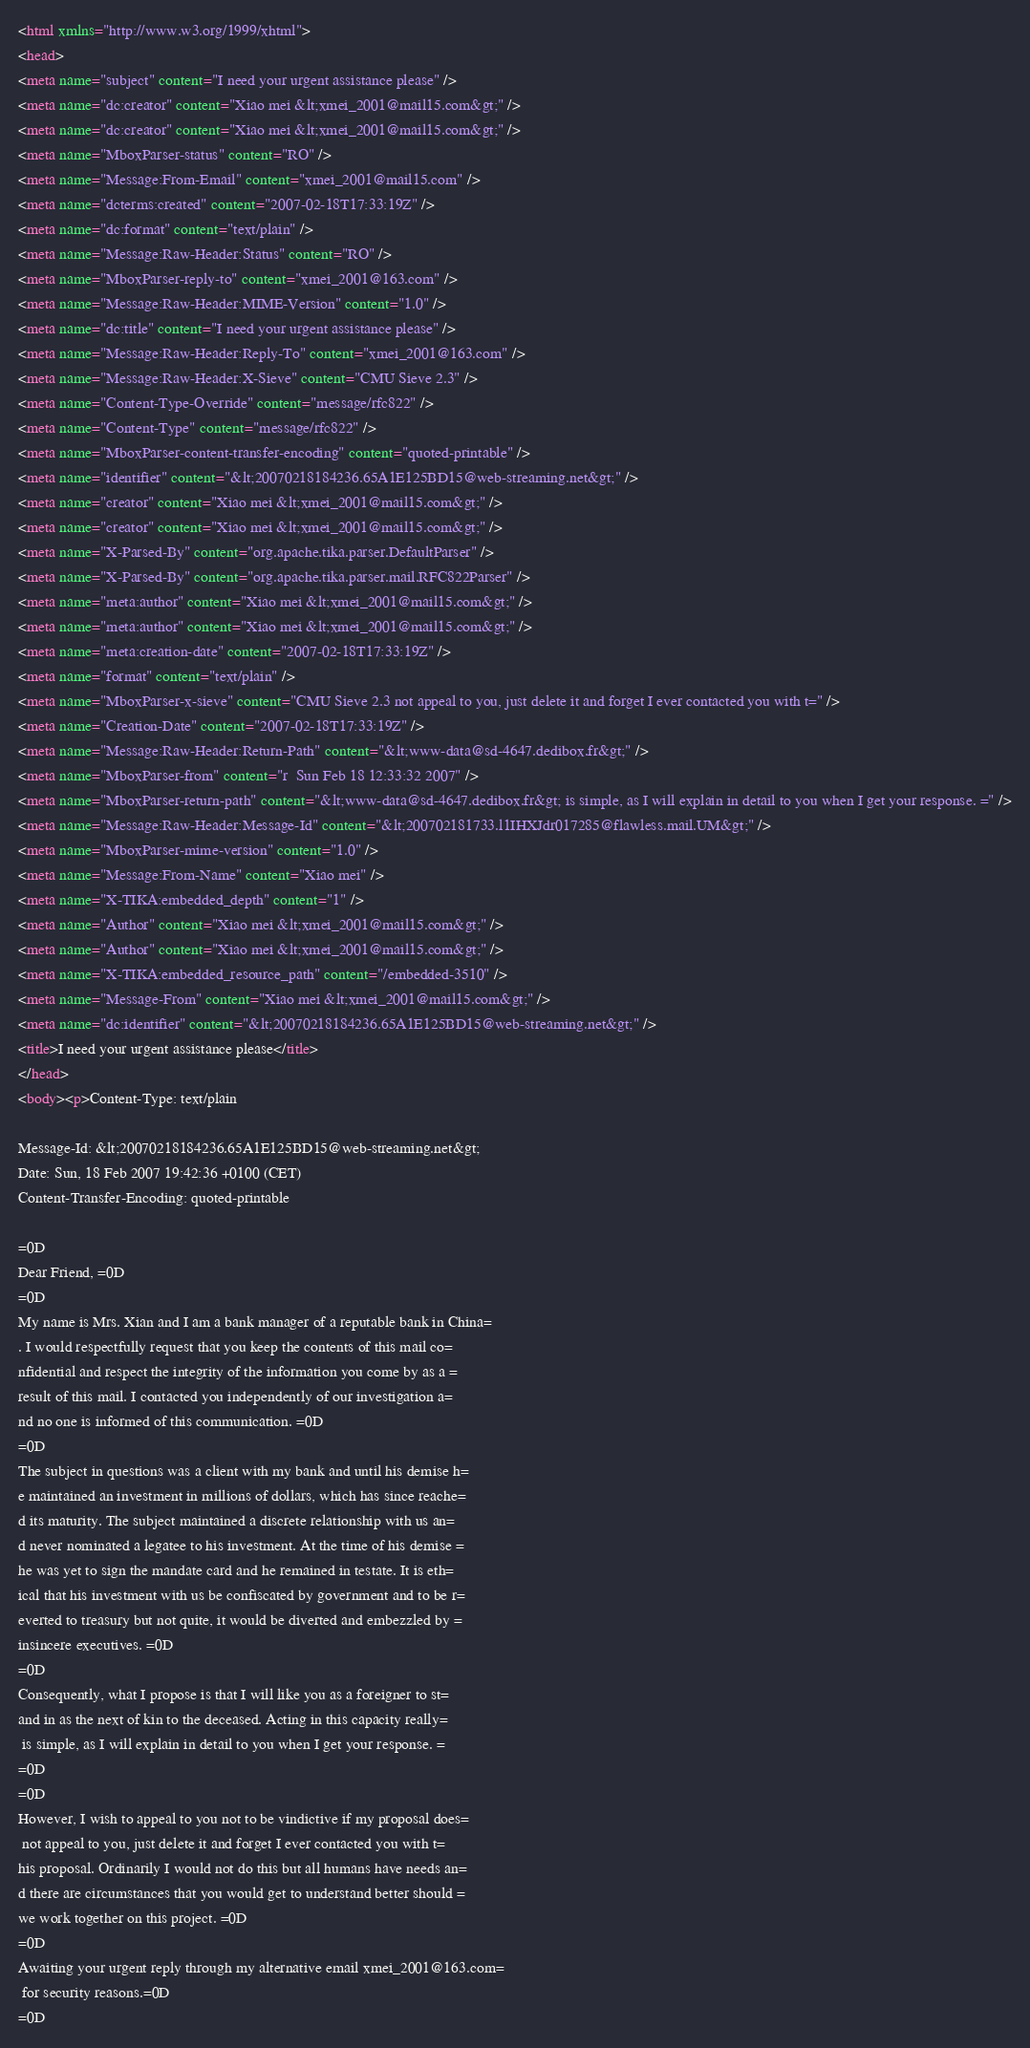<code> <loc_0><loc_0><loc_500><loc_500><_HTML_><html xmlns="http://www.w3.org/1999/xhtml">
<head>
<meta name="subject" content="I need your urgent assistance please" />
<meta name="dc:creator" content="Xiao mei &lt;xmei_2001@mail15.com&gt;" />
<meta name="dc:creator" content="Xiao mei &lt;xmei_2001@mail15.com&gt;" />
<meta name="MboxParser-status" content="RO" />
<meta name="Message:From-Email" content="xmei_2001@mail15.com" />
<meta name="dcterms:created" content="2007-02-18T17:33:19Z" />
<meta name="dc:format" content="text/plain" />
<meta name="Message:Raw-Header:Status" content="RO" />
<meta name="MboxParser-reply-to" content="xmei_2001@163.com" />
<meta name="Message:Raw-Header:MIME-Version" content="1.0" />
<meta name="dc:title" content="I need your urgent assistance please" />
<meta name="Message:Raw-Header:Reply-To" content="xmei_2001@163.com" />
<meta name="Message:Raw-Header:X-Sieve" content="CMU Sieve 2.3" />
<meta name="Content-Type-Override" content="message/rfc822" />
<meta name="Content-Type" content="message/rfc822" />
<meta name="MboxParser-content-transfer-encoding" content="quoted-printable" />
<meta name="identifier" content="&lt;20070218184236.65A1E125BD15@web-streaming.net&gt;" />
<meta name="creator" content="Xiao mei &lt;xmei_2001@mail15.com&gt;" />
<meta name="creator" content="Xiao mei &lt;xmei_2001@mail15.com&gt;" />
<meta name="X-Parsed-By" content="org.apache.tika.parser.DefaultParser" />
<meta name="X-Parsed-By" content="org.apache.tika.parser.mail.RFC822Parser" />
<meta name="meta:author" content="Xiao mei &lt;xmei_2001@mail15.com&gt;" />
<meta name="meta:author" content="Xiao mei &lt;xmei_2001@mail15.com&gt;" />
<meta name="meta:creation-date" content="2007-02-18T17:33:19Z" />
<meta name="format" content="text/plain" />
<meta name="MboxParser-x-sieve" content="CMU Sieve 2.3 not appeal to you, just delete it and forget I ever contacted you with t=" />
<meta name="Creation-Date" content="2007-02-18T17:33:19Z" />
<meta name="Message:Raw-Header:Return-Path" content="&lt;www-data@sd-4647.dedibox.fr&gt;" />
<meta name="MboxParser-from" content="r  Sun Feb 18 12:33:32 2007" />
<meta name="MboxParser-return-path" content="&lt;www-data@sd-4647.dedibox.fr&gt; is simple, as I will explain in detail to you when I get your response. =" />
<meta name="Message:Raw-Header:Message-Id" content="&lt;200702181733.l1IHXJdr017285@flawless.mail.UM&gt;" />
<meta name="MboxParser-mime-version" content="1.0" />
<meta name="Message:From-Name" content="Xiao mei" />
<meta name="X-TIKA:embedded_depth" content="1" />
<meta name="Author" content="Xiao mei &lt;xmei_2001@mail15.com&gt;" />
<meta name="Author" content="Xiao mei &lt;xmei_2001@mail15.com&gt;" />
<meta name="X-TIKA:embedded_resource_path" content="/embedded-3510" />
<meta name="Message-From" content="Xiao mei &lt;xmei_2001@mail15.com&gt;" />
<meta name="dc:identifier" content="&lt;20070218184236.65A1E125BD15@web-streaming.net&gt;" />
<title>I need your urgent assistance please</title>
</head>
<body><p>Content-Type: text/plain

Message-Id: &lt;20070218184236.65A1E125BD15@web-streaming.net&gt;
Date: Sun, 18 Feb 2007 19:42:36 +0100 (CET)
Content-Transfer-Encoding: quoted-printable

=0D
Dear Friend, =0D
=0D
My name is Mrs. Xian and I am a bank manager of a reputable bank in China=
. I would respectfully request that you keep the contents of this mail co=
nfidential and respect the integrity of the information you come by as a =
result of this mail. I contacted you independently of our investigation a=
nd no one is informed of this communication. =0D
=0D
The subject in questions was a client with my bank and until his demise h=
e maintained an investment in millions of dollars, which has since reache=
d its maturity. The subject maintained a discrete relationship with us an=
d never nominated a legatee to his investment. At the time of his demise =
he was yet to sign the mandate card and he remained in testate. It is eth=
ical that his investment with us be confiscated by government and to be r=
everted to treasury but not quite, it would be diverted and embezzled by =
insincere executives. =0D
=0D
Consequently, what I propose is that I will like you as a foreigner to st=
and in as the next of kin to the deceased. Acting in this capacity really=
 is simple, as I will explain in detail to you when I get your response. =
=0D
=0D
However, I wish to appeal to you not to be vindictive if my proposal does=
 not appeal to you, just delete it and forget I ever contacted you with t=
his proposal. Ordinarily I would not do this but all humans have needs an=
d there are circumstances that you would get to understand better should =
we work together on this project. =0D
=0D
Awaiting your urgent reply through my alternative email xmei_2001@163.com=
 for security reasons.=0D
=0D</code> 